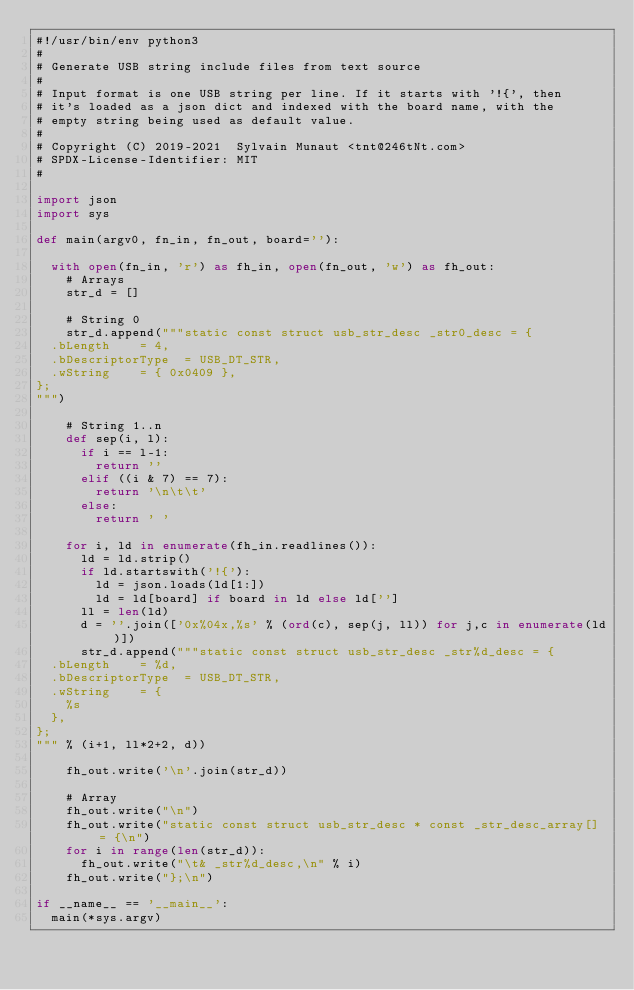<code> <loc_0><loc_0><loc_500><loc_500><_Python_>#!/usr/bin/env python3
#
# Generate USB string include files from text source
#
# Input format is one USB string per line. If it starts with '!{', then
# it's loaded as a json dict and indexed with the board name, with the
# empty string being used as default value.
#
# Copyright (C) 2019-2021  Sylvain Munaut <tnt@246tNt.com>
# SPDX-License-Identifier: MIT
#

import json
import sys

def main(argv0, fn_in, fn_out, board=''):

	with open(fn_in, 'r') as fh_in, open(fn_out, 'w') as fh_out:
		# Arrays
		str_d = []

		# String 0
		str_d.append("""static const struct usb_str_desc _str0_desc = {
	.bLength		= 4,
	.bDescriptorType	= USB_DT_STR,
	.wString		= { 0x0409 },
};
""")

		# String 1..n
		def sep(i, l):
			if i == l-1:
				return ''
			elif ((i & 7) == 7):
				return '\n\t\t'
			else:
				return ' '

		for i, ld in enumerate(fh_in.readlines()):
			ld = ld.strip()
			if ld.startswith('!{'):
				ld = json.loads(ld[1:])
				ld = ld[board] if board in ld else ld['']
			ll = len(ld)
			d = ''.join(['0x%04x,%s' % (ord(c), sep(j, ll)) for j,c in enumerate(ld)])
			str_d.append("""static const struct usb_str_desc _str%d_desc = {
	.bLength		= %d,
	.bDescriptorType	= USB_DT_STR,
	.wString		= {
		%s
	},
};
""" % (i+1, ll*2+2, d))

		fh_out.write('\n'.join(str_d))

		# Array
		fh_out.write("\n")
		fh_out.write("static const struct usb_str_desc * const _str_desc_array[] = {\n")
		for i in range(len(str_d)):
			fh_out.write("\t& _str%d_desc,\n" % i)
		fh_out.write("};\n")

if __name__ == '__main__':
	main(*sys.argv)
</code> 